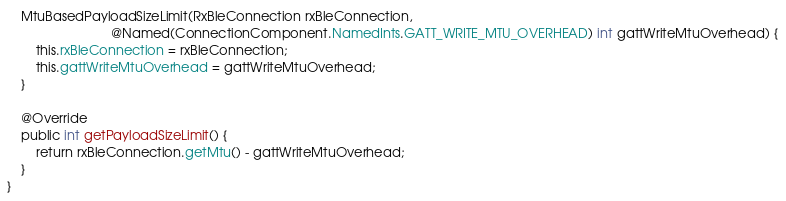<code> <loc_0><loc_0><loc_500><loc_500><_Java_>    MtuBasedPayloadSizeLimit(RxBleConnection rxBleConnection,
                             @Named(ConnectionComponent.NamedInts.GATT_WRITE_MTU_OVERHEAD) int gattWriteMtuOverhead) {
        this.rxBleConnection = rxBleConnection;
        this.gattWriteMtuOverhead = gattWriteMtuOverhead;
    }

    @Override
    public int getPayloadSizeLimit() {
        return rxBleConnection.getMtu() - gattWriteMtuOverhead;
    }
}
</code> 